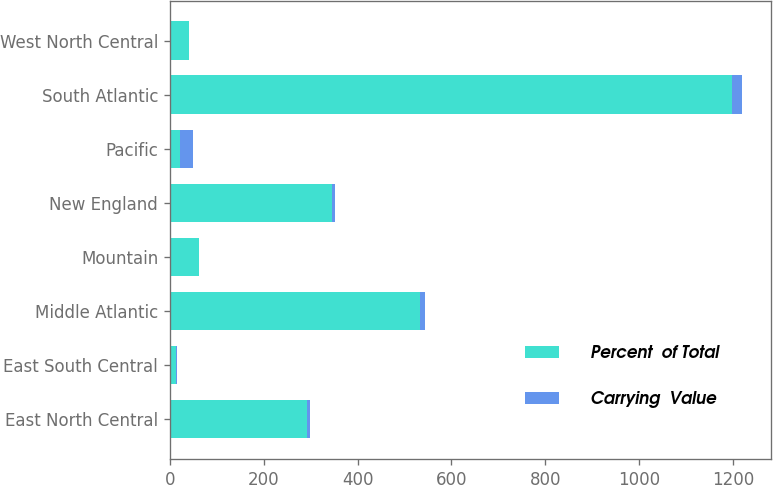Convert chart. <chart><loc_0><loc_0><loc_500><loc_500><stacked_bar_chart><ecel><fcel>East North Central<fcel>East South Central<fcel>Middle Atlantic<fcel>Mountain<fcel>New England<fcel>Pacific<fcel>South Atlantic<fcel>West North Central<nl><fcel>Percent  of Total<fcel>293<fcel>14<fcel>534<fcel>61<fcel>345<fcel>21<fcel>1198<fcel>40<nl><fcel>Carrying  Value<fcel>5.1<fcel>0.2<fcel>9.4<fcel>1.1<fcel>6.1<fcel>28.3<fcel>21<fcel>0.7<nl></chart> 